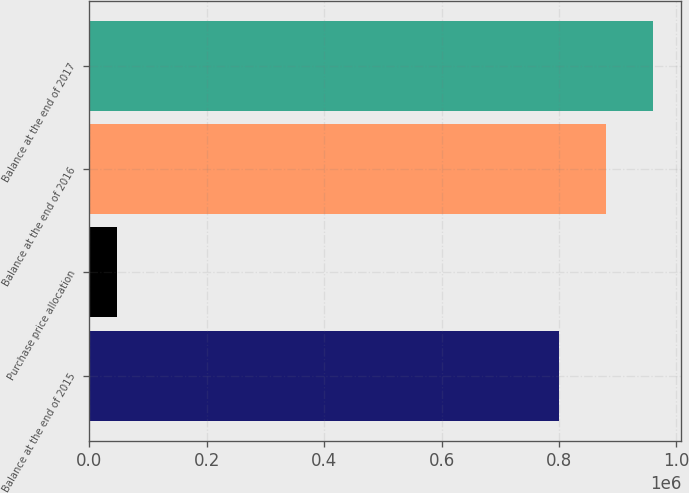Convert chart to OTSL. <chart><loc_0><loc_0><loc_500><loc_500><bar_chart><fcel>Balance at the end of 2015<fcel>Purchase price allocation<fcel>Balance at the end of 2016<fcel>Balance at the end of 2017<nl><fcel>799182<fcel>46940<fcel>879788<fcel>960395<nl></chart> 